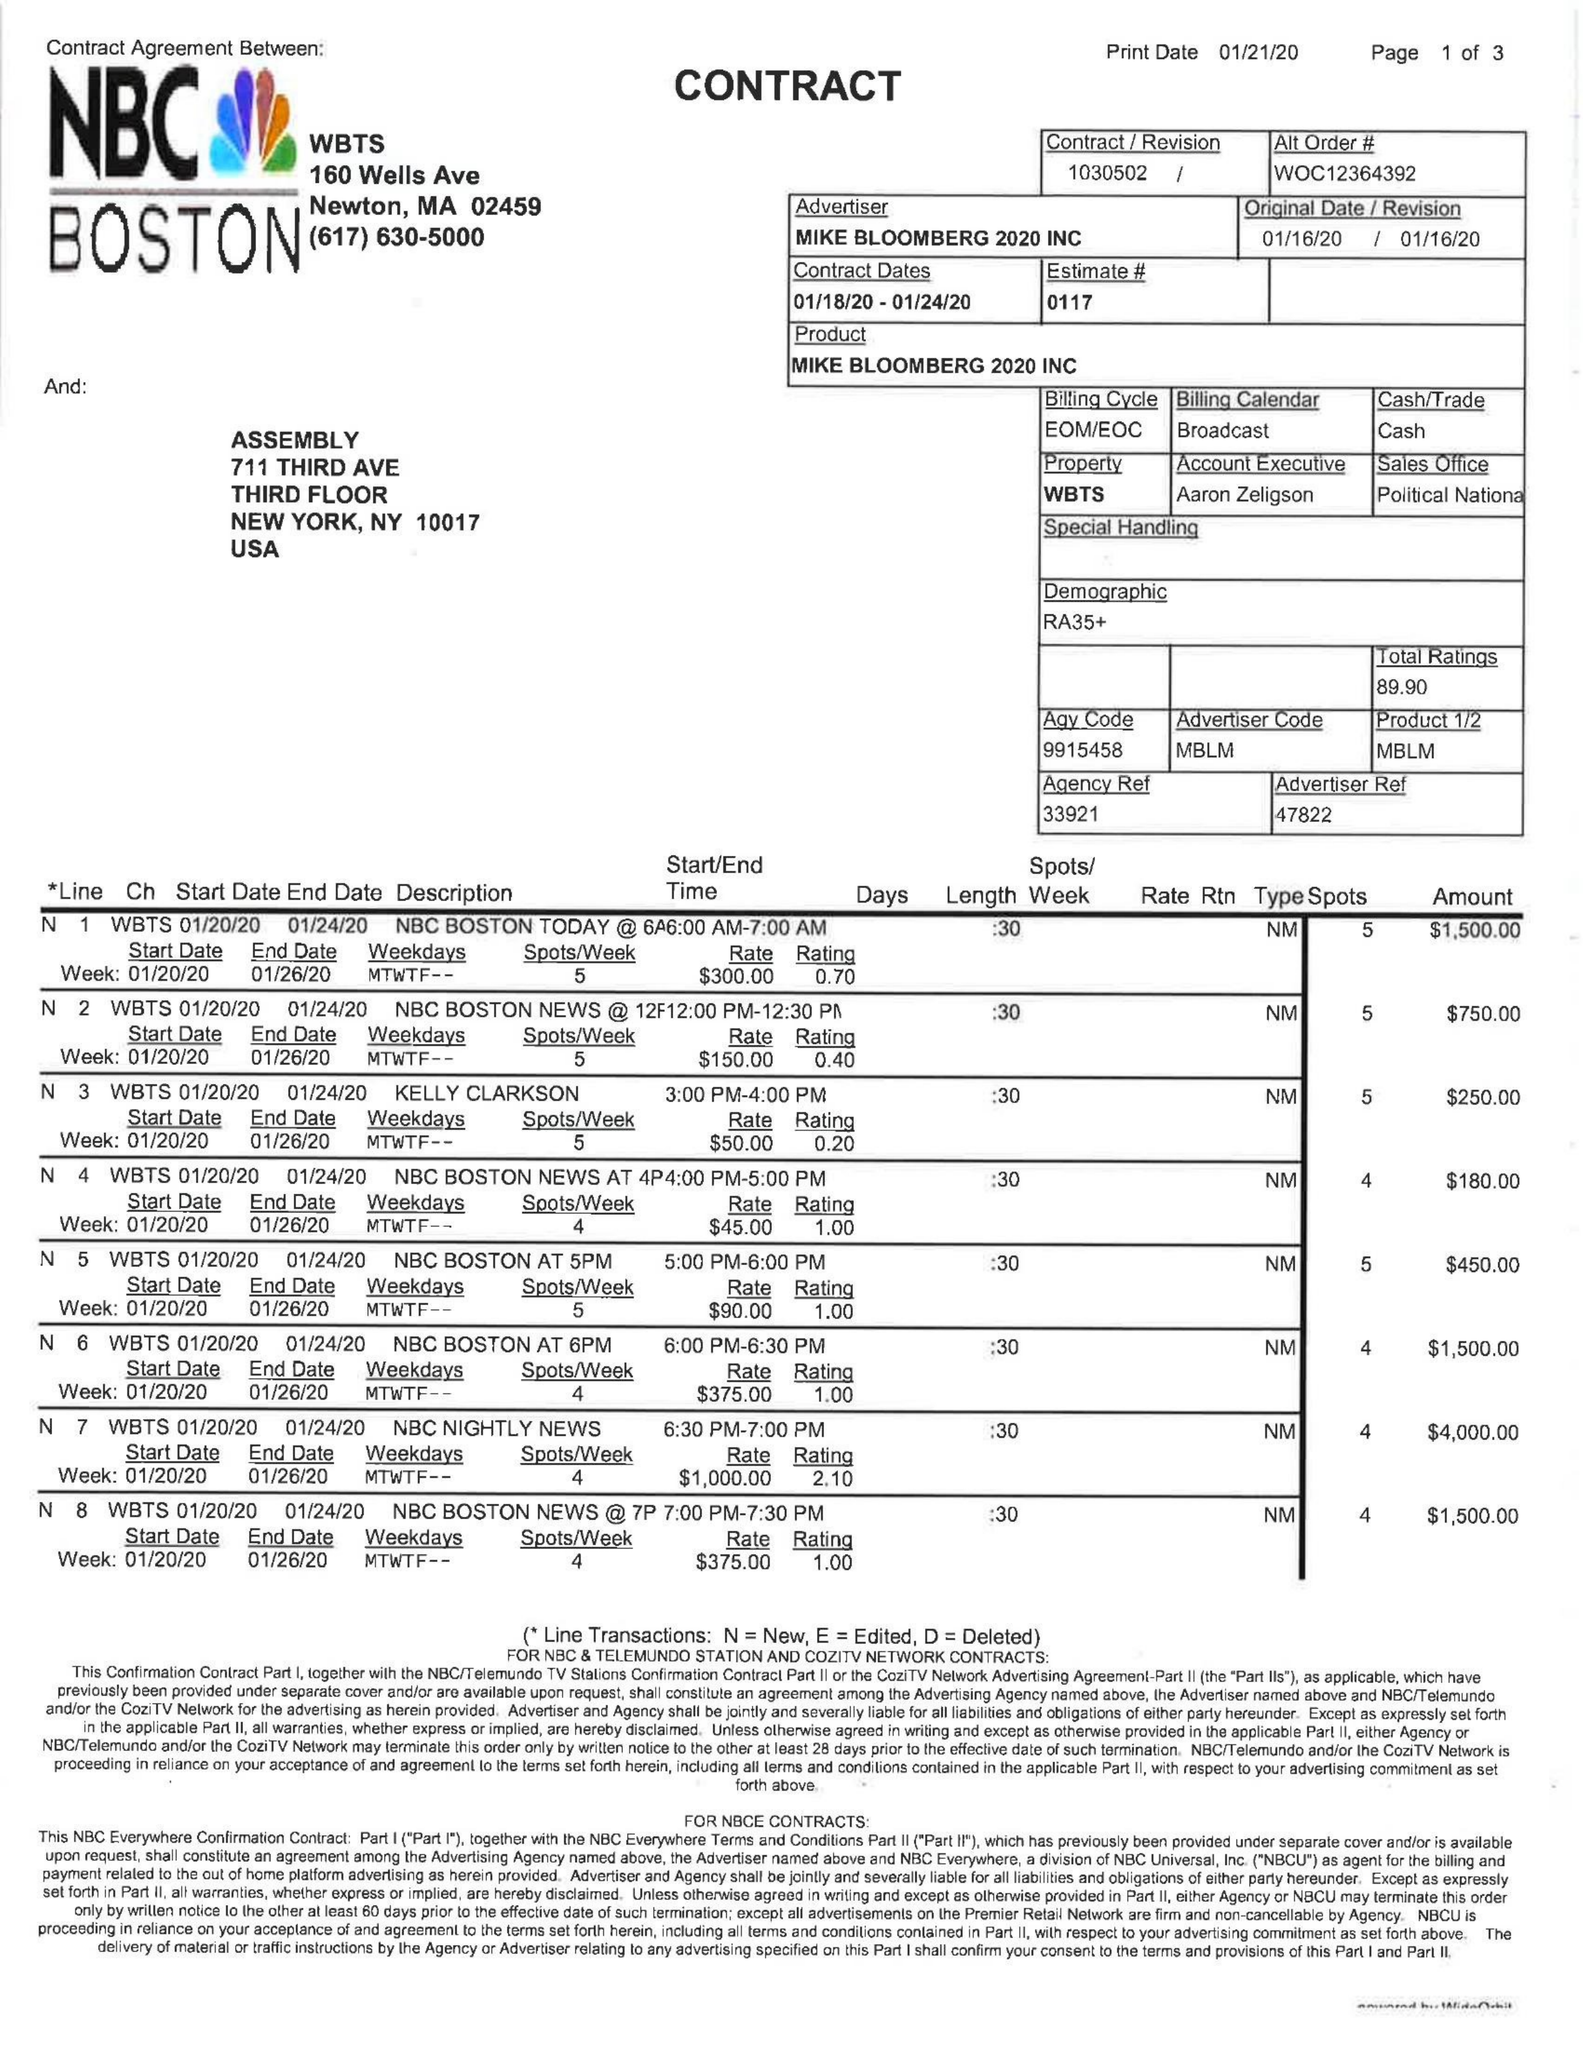What is the value for the contract_num?
Answer the question using a single word or phrase. 1030502 